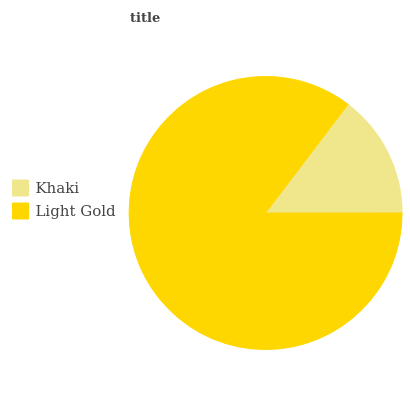Is Khaki the minimum?
Answer yes or no. Yes. Is Light Gold the maximum?
Answer yes or no. Yes. Is Light Gold the minimum?
Answer yes or no. No. Is Light Gold greater than Khaki?
Answer yes or no. Yes. Is Khaki less than Light Gold?
Answer yes or no. Yes. Is Khaki greater than Light Gold?
Answer yes or no. No. Is Light Gold less than Khaki?
Answer yes or no. No. Is Light Gold the high median?
Answer yes or no. Yes. Is Khaki the low median?
Answer yes or no. Yes. Is Khaki the high median?
Answer yes or no. No. Is Light Gold the low median?
Answer yes or no. No. 